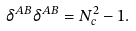Convert formula to latex. <formula><loc_0><loc_0><loc_500><loc_500>\delta ^ { A B } \delta ^ { A B } = N _ { c } ^ { 2 } - 1 .</formula> 